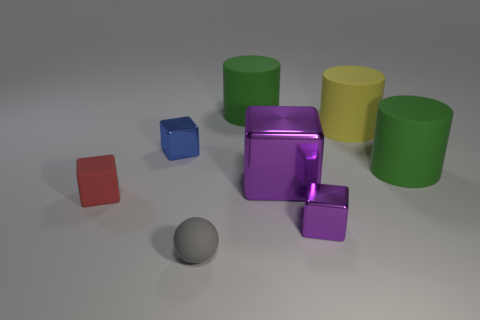Does the small metal object right of the tiny ball have the same color as the big shiny thing?
Ensure brevity in your answer.  Yes. There is a tiny cube that is behind the rubber thing left of the gray matte sphere; is there a large purple metal thing right of it?
Make the answer very short. Yes. Is there anything else that has the same shape as the tiny gray rubber thing?
Provide a succinct answer. No. Is the color of the small cube that is to the right of the big purple thing the same as the big block in front of the tiny blue shiny block?
Keep it short and to the point. Yes. Are any big green metal things visible?
Your answer should be compact. No. There is a small thing that is the same color as the large metallic cube; what is its material?
Provide a short and direct response. Metal. What size is the block on the left side of the small metal cube that is left of the small thing that is in front of the tiny purple thing?
Your answer should be compact. Small. Is the shape of the blue metal object the same as the green thing in front of the tiny blue metallic object?
Make the answer very short. No. Are there any large matte things that have the same color as the big metal cube?
Make the answer very short. No. What number of cylinders are small things or big matte objects?
Keep it short and to the point. 3. 